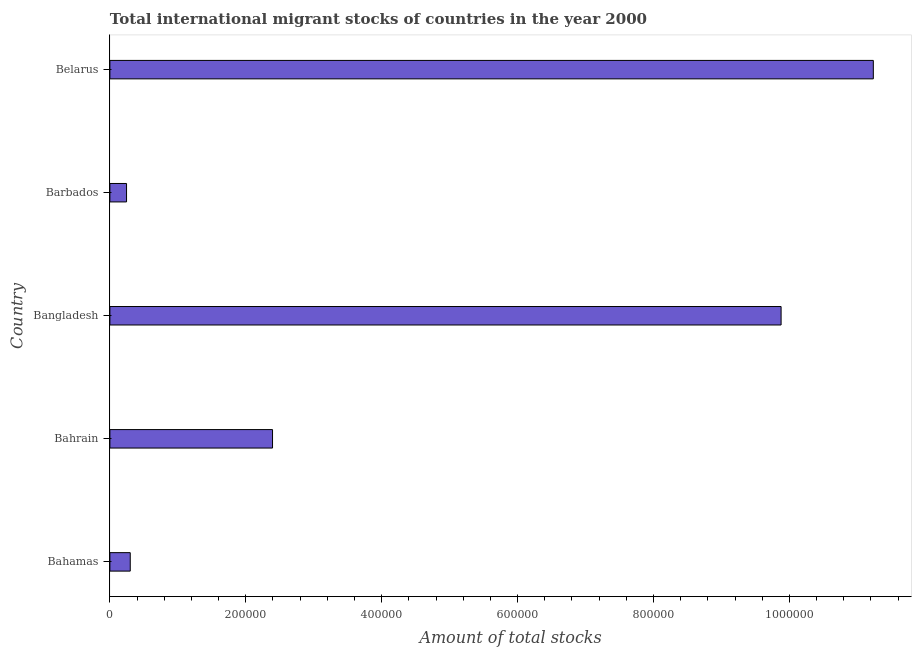Does the graph contain any zero values?
Ensure brevity in your answer.  No. What is the title of the graph?
Provide a succinct answer. Total international migrant stocks of countries in the year 2000. What is the label or title of the X-axis?
Keep it short and to the point. Amount of total stocks. What is the label or title of the Y-axis?
Provide a short and direct response. Country. What is the total number of international migrant stock in Belarus?
Keep it short and to the point. 1.12e+06. Across all countries, what is the maximum total number of international migrant stock?
Provide a short and direct response. 1.12e+06. Across all countries, what is the minimum total number of international migrant stock?
Your answer should be compact. 2.45e+04. In which country was the total number of international migrant stock maximum?
Provide a succinct answer. Belarus. In which country was the total number of international migrant stock minimum?
Offer a terse response. Barbados. What is the sum of the total number of international migrant stock?
Give a very brief answer. 2.41e+06. What is the difference between the total number of international migrant stock in Barbados and Belarus?
Your answer should be compact. -1.10e+06. What is the average total number of international migrant stock per country?
Give a very brief answer. 4.81e+05. What is the median total number of international migrant stock?
Offer a very short reply. 2.39e+05. Is the total number of international migrant stock in Barbados less than that in Belarus?
Provide a short and direct response. Yes. What is the difference between the highest and the second highest total number of international migrant stock?
Give a very brief answer. 1.36e+05. Is the sum of the total number of international migrant stock in Bahamas and Bangladesh greater than the maximum total number of international migrant stock across all countries?
Give a very brief answer. No. What is the difference between the highest and the lowest total number of international migrant stock?
Give a very brief answer. 1.10e+06. How many bars are there?
Give a very brief answer. 5. Are all the bars in the graph horizontal?
Your answer should be very brief. Yes. How many countries are there in the graph?
Provide a succinct answer. 5. What is the difference between two consecutive major ticks on the X-axis?
Keep it short and to the point. 2.00e+05. What is the Amount of total stocks of Bahamas?
Offer a terse response. 3.00e+04. What is the Amount of total stocks of Bahrain?
Your answer should be compact. 2.39e+05. What is the Amount of total stocks of Bangladesh?
Offer a terse response. 9.88e+05. What is the Amount of total stocks in Barbados?
Keep it short and to the point. 2.45e+04. What is the Amount of total stocks of Belarus?
Provide a succinct answer. 1.12e+06. What is the difference between the Amount of total stocks in Bahamas and Bahrain?
Give a very brief answer. -2.09e+05. What is the difference between the Amount of total stocks in Bahamas and Bangladesh?
Make the answer very short. -9.58e+05. What is the difference between the Amount of total stocks in Bahamas and Barbados?
Offer a very short reply. 5443. What is the difference between the Amount of total stocks in Bahamas and Belarus?
Provide a succinct answer. -1.09e+06. What is the difference between the Amount of total stocks in Bahrain and Bangladesh?
Provide a succinct answer. -7.48e+05. What is the difference between the Amount of total stocks in Bahrain and Barbados?
Ensure brevity in your answer.  2.15e+05. What is the difference between the Amount of total stocks in Bahrain and Belarus?
Offer a very short reply. -8.84e+05. What is the difference between the Amount of total stocks in Bangladesh and Barbados?
Your answer should be very brief. 9.63e+05. What is the difference between the Amount of total stocks in Bangladesh and Belarus?
Your response must be concise. -1.36e+05. What is the difference between the Amount of total stocks in Barbados and Belarus?
Your answer should be very brief. -1.10e+06. What is the ratio of the Amount of total stocks in Bahamas to that in Bahrain?
Provide a succinct answer. 0.12. What is the ratio of the Amount of total stocks in Bahamas to that in Bangladesh?
Provide a succinct answer. 0.03. What is the ratio of the Amount of total stocks in Bahamas to that in Barbados?
Ensure brevity in your answer.  1.22. What is the ratio of the Amount of total stocks in Bahamas to that in Belarus?
Ensure brevity in your answer.  0.03. What is the ratio of the Amount of total stocks in Bahrain to that in Bangladesh?
Provide a short and direct response. 0.24. What is the ratio of the Amount of total stocks in Bahrain to that in Barbados?
Your answer should be compact. 9.77. What is the ratio of the Amount of total stocks in Bahrain to that in Belarus?
Provide a short and direct response. 0.21. What is the ratio of the Amount of total stocks in Bangladesh to that in Barbados?
Keep it short and to the point. 40.31. What is the ratio of the Amount of total stocks in Bangladesh to that in Belarus?
Offer a terse response. 0.88. What is the ratio of the Amount of total stocks in Barbados to that in Belarus?
Offer a very short reply. 0.02. 